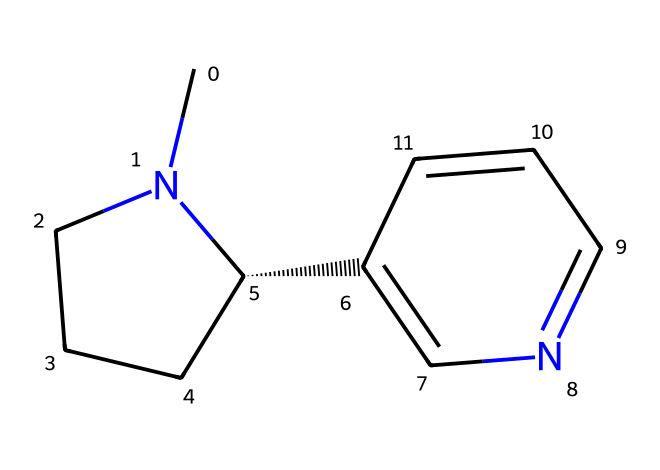What is the name of the chemical represented by this SMILES? The SMILES representation corresponds to nicotine, a well-known alkaloid found in tobacco. The structure indicates specific characteristics that match the known structure of nicotine.
Answer: nicotine How many rings are present in the chemical structure? By examining the structure, there are two distinct rings represented; one is a piperidine ring while the other is a pyridine ring. Counting both gives us two rings in total.
Answer: 2 What is the total number of nitrogen atoms in this chemical? The structure shows two nitrogen atoms present within the rings, specifically located in the piperidine and pyridine components of the molecule.
Answer: 2 What type of chemical bonding is predominantly found in this alkaloid? The structure depicts a combination of single and double bonds, but particularly, the presence of carbon-nitrogen bonds (as seen in the nitrogen positions) is significant in alkaloids like nicotine.
Answer: carbon-nitrogen bonds What property is primarily responsible for the addictive nature of this alkaloid? The presence of the nitrogen atom is critical as it is linked to creating interactions with the nicotinic acetylcholine receptors in the brain, leading to its addictive properties.
Answer: nitrogen atom How does the arrangement of the atoms affect its pharmacological action? The specific spatial arrangement, including stereochemistry (indicated by the chiral center in the structure), allows nicotine to effectively bind to its receptors, influencing its pharmacological actions, including addiction.
Answer: spatial arrangement What is the primary functional group present in nicotine? The structure includes a nitrogen atom that characterizes it as an amine. This functional group is significant in defining its behavior and reactivity as an alkaloid.
Answer: amine 